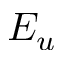Convert formula to latex. <formula><loc_0><loc_0><loc_500><loc_500>E _ { u }</formula> 